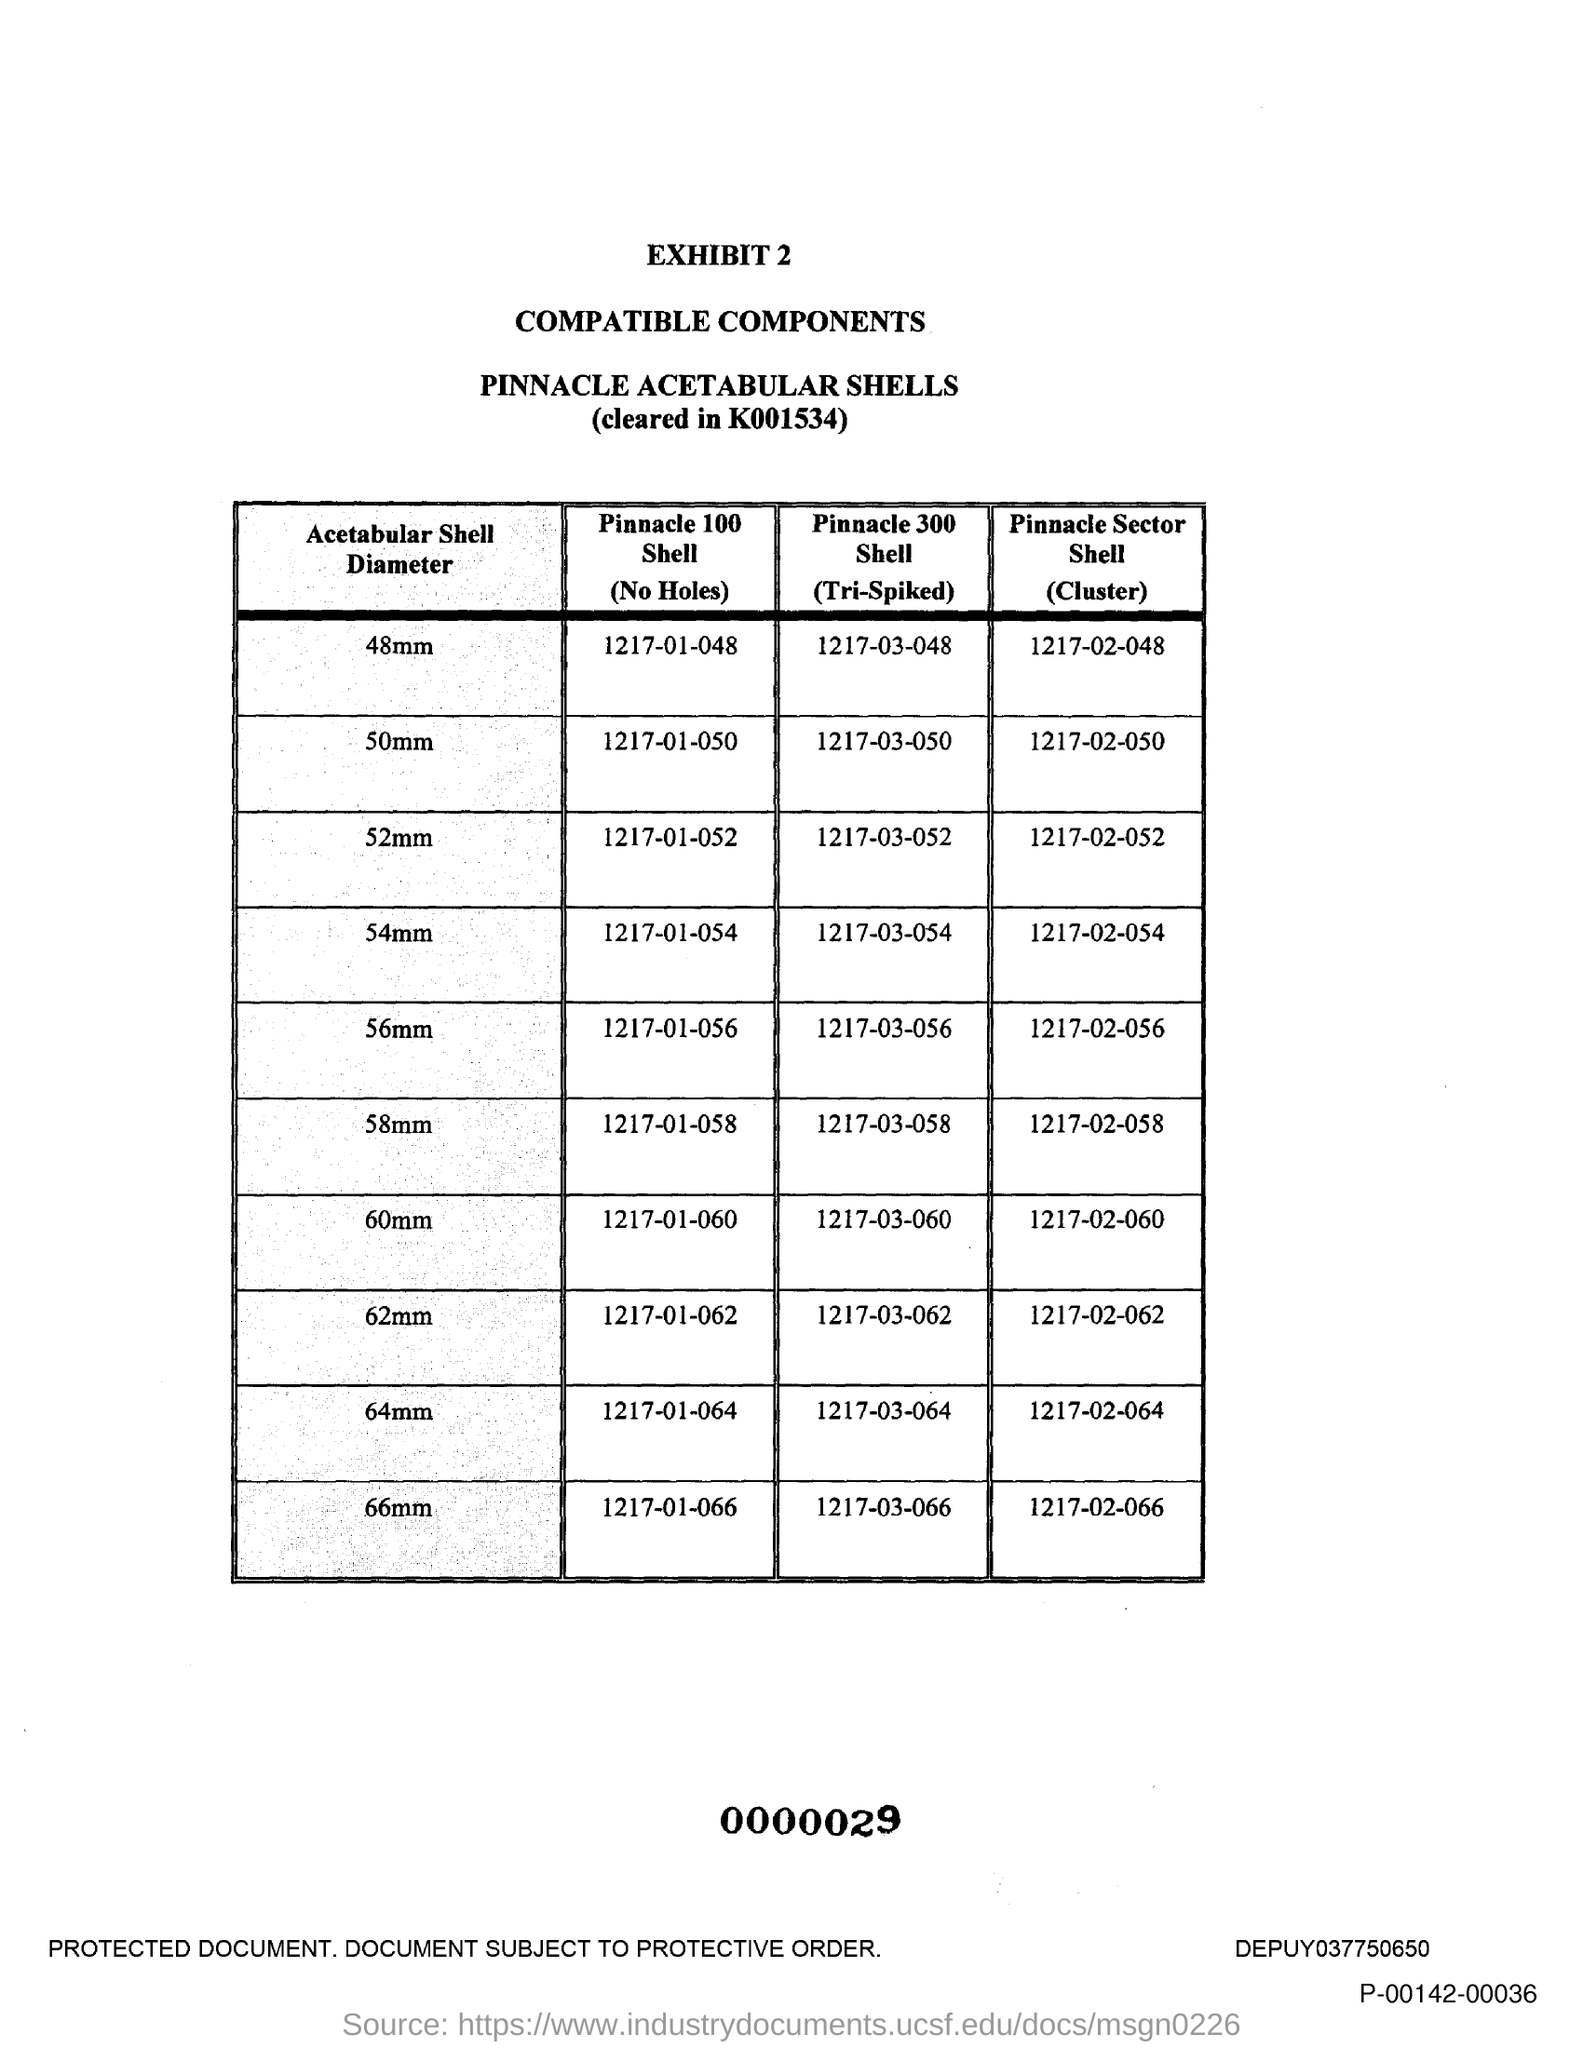Indicate a few pertinent items in this graphic. The Pinnacle 100 shell (No Holes) is a 48mm size suitable for use in various applications. The Pinnacle 100 shell with no holes, specifically for a 58mm size, is a protective covering for electrical components that is known as "1217-01-058..". The Pinnacle 100 shell with no holes, specifically for 64mm, is referred to as 1217-01-064. The Pinnacle 100 shell (No Holes) with a diameter of 50mm is a specific type of component that can be identified by the code 1217-01-050. The Pinnacle 100 shell, with no holes, is designed for 62mm diameter rods. Its model number is 1217-01-062. 